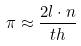Convert formula to latex. <formula><loc_0><loc_0><loc_500><loc_500>\pi \approx \frac { 2 l \cdot n } { t h }</formula> 